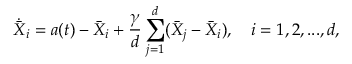Convert formula to latex. <formula><loc_0><loc_0><loc_500><loc_500>\dot { \bar { X } } _ { i } = a ( t ) - \bar { X } _ { i } + \frac { \gamma } { d } \sum _ { j = 1 } ^ { d } ( \bar { X } _ { j } - \bar { X } _ { i } ) , \quad i = 1 , 2 , \dots , d ,</formula> 